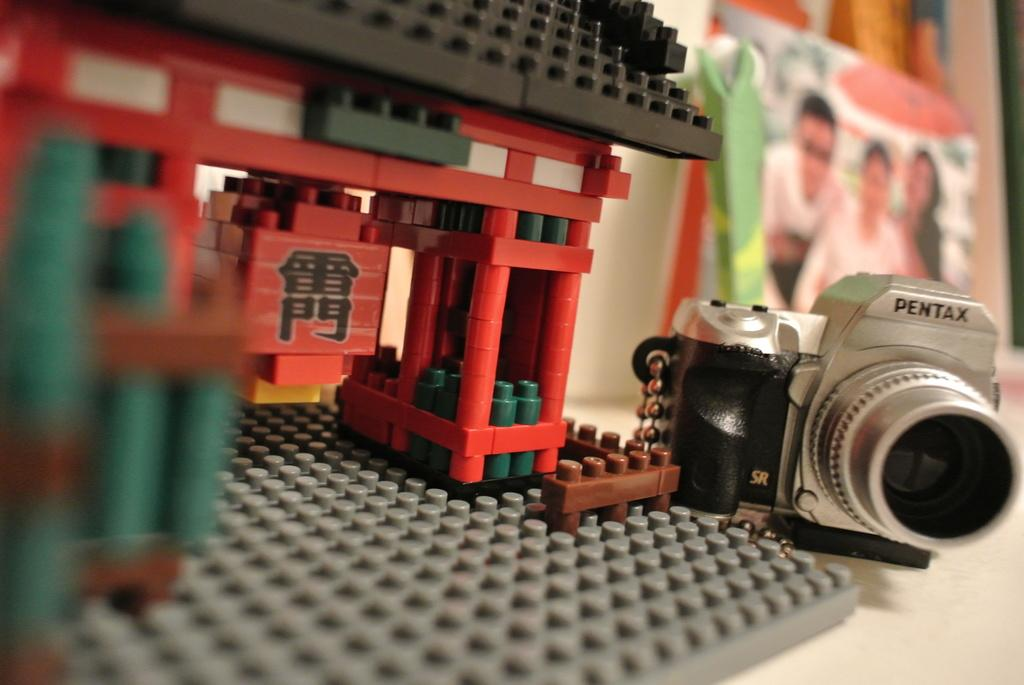What is located at the bottom of the image? There is a table at the bottom of the image. What objects are on the table? There is a lego toy, a camera, and a bag on the table. What type of flag is visible on the table in the image? There is no flag present on the table in the image. 